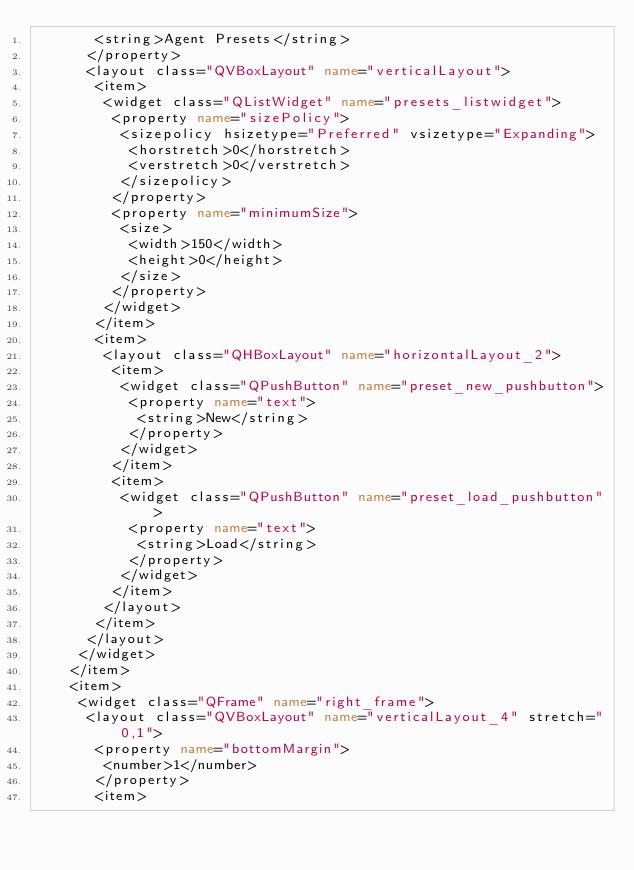Convert code to text. <code><loc_0><loc_0><loc_500><loc_500><_XML_>       <string>Agent Presets</string>
      </property>
      <layout class="QVBoxLayout" name="verticalLayout">
       <item>
        <widget class="QListWidget" name="presets_listwidget">
         <property name="sizePolicy">
          <sizepolicy hsizetype="Preferred" vsizetype="Expanding">
           <horstretch>0</horstretch>
           <verstretch>0</verstretch>
          </sizepolicy>
         </property>
         <property name="minimumSize">
          <size>
           <width>150</width>
           <height>0</height>
          </size>
         </property>
        </widget>
       </item>
       <item>
        <layout class="QHBoxLayout" name="horizontalLayout_2">
         <item>
          <widget class="QPushButton" name="preset_new_pushbutton">
           <property name="text">
            <string>New</string>
           </property>
          </widget>
         </item>
         <item>
          <widget class="QPushButton" name="preset_load_pushbutton">
           <property name="text">
            <string>Load</string>
           </property>
          </widget>
         </item>
        </layout>
       </item>
      </layout>
     </widget>
    </item>
    <item>
     <widget class="QFrame" name="right_frame">
      <layout class="QVBoxLayout" name="verticalLayout_4" stretch="0,1">
       <property name="bottomMargin">
        <number>1</number>
       </property>
       <item></code> 